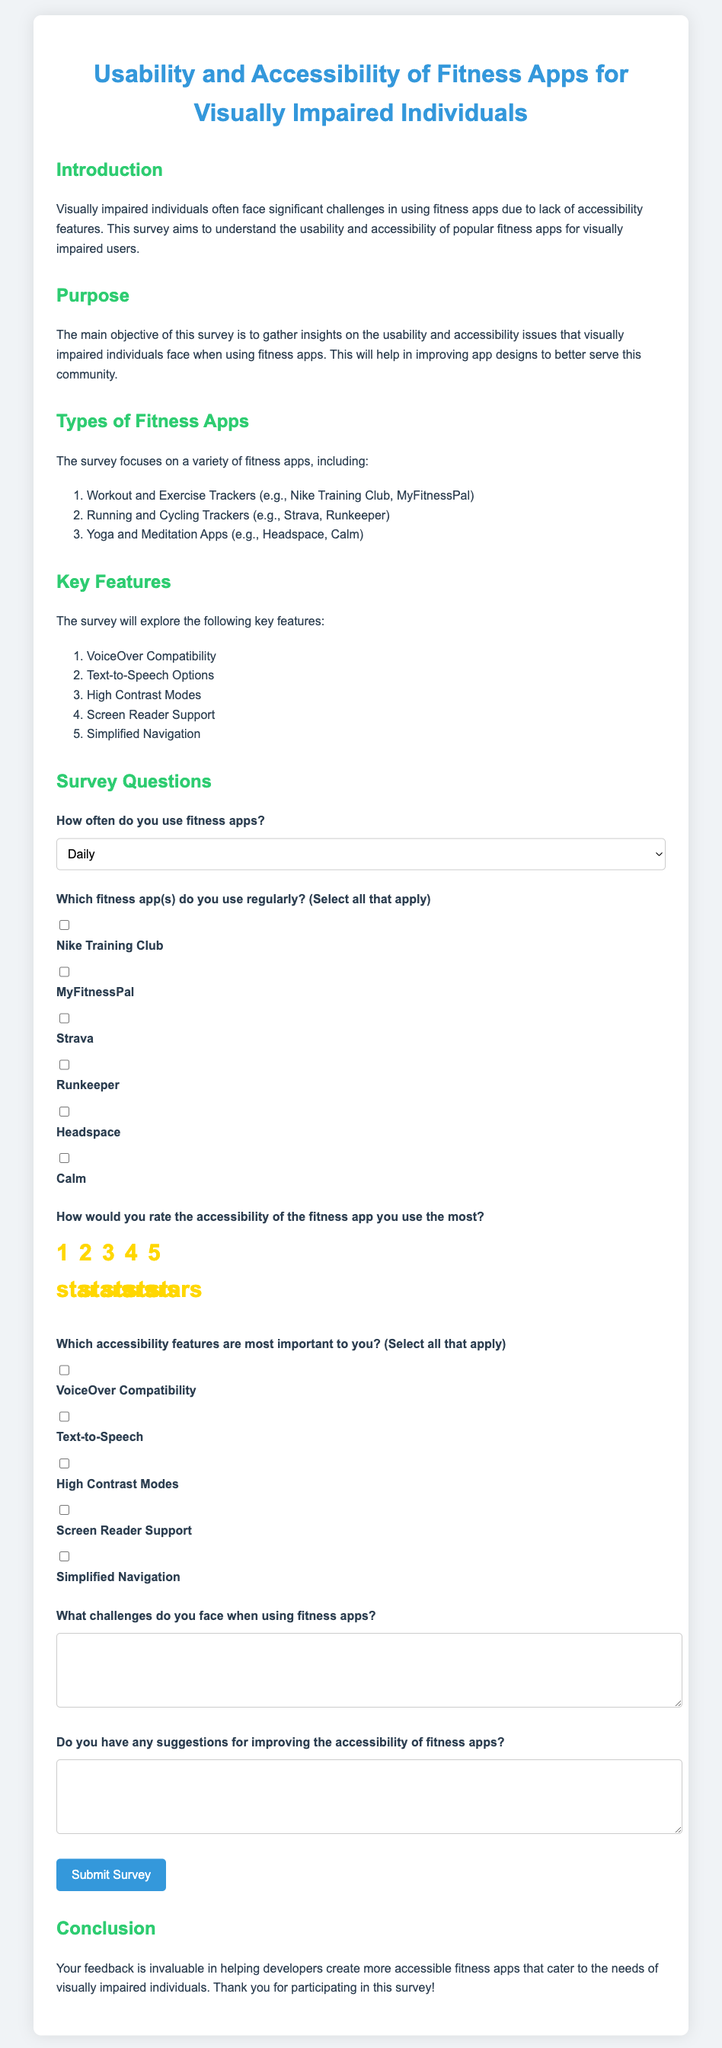What is the title of the survey? The title is prominently displayed at the top of the document and is "Usability and Accessibility of Fitness Apps for Visually Impaired Individuals."
Answer: Usability and Accessibility of Fitness Apps for Visually Impaired Individuals What types of fitness apps are mentioned in the survey? The survey outlines three categories of fitness apps: Workout and Exercise Trackers, Running and Cycling Trackers, and Yoga and Meditation Apps.
Answer: Workout and Exercise Trackers, Running and Cycling Trackers, Yoga and Meditation Apps How many key features does the survey explore? The survey lists five key features that will be explored, which are important for assessing accessibility in fitness apps.
Answer: Five What is the purpose of the survey? The document states that the survey aims to gather insights on the usability and accessibility issues that visually impaired individuals face when using fitness apps.
Answer: To gather insights on usability and accessibility issues Which app is listed first under the commonly used fitness apps? The survey lists "Nike Training Club" as the first app under the commonly used fitness apps section.
Answer: Nike Training Club How would users rate the accessibility of the fitness app they use the most? The survey includes a question with a radio button format where users can select their rating from one to five stars, indicating their assessment of accessibility.
Answer: Five stars (or 1-5 depending on their choice) What is one suggested way to improve accessibility according to survey questions? The survey specifically asks for suggestions from participants on improving accessibility, allowing them to express their thoughts directly in a text area.
Answer: Suggestions (varies by respondent) What color is primarily used for the title in the document? The title is styled with a specific color defined in the document's CSS, which is a shade of blue.
Answer: Blue How often can participants indicate their frequency of using fitness apps? There are five options available for participants to select how often they use fitness apps, indicating various frequencies from daily to never.
Answer: Daily (or any frequency they select) What do you need to do to submit the survey? To submit the survey, participants need to complete the questions in the form and click the "Submit Survey" button at the end of the document.
Answer: Click the "Submit Survey" button 